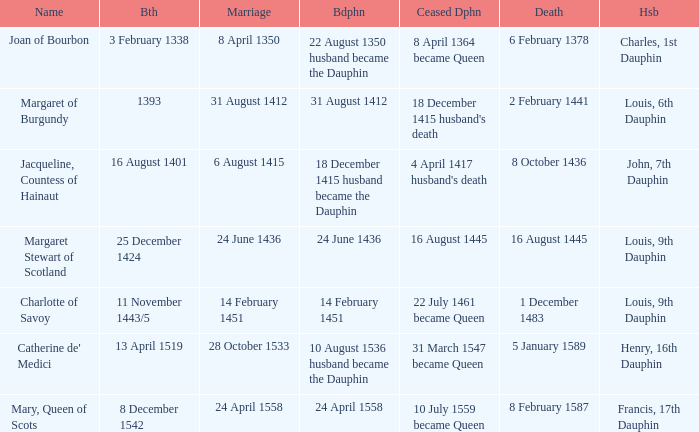When was the marriage when became dauphine is 31 august 1412? 31 August 1412. 